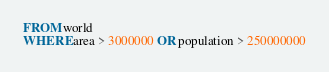Convert code to text. <code><loc_0><loc_0><loc_500><loc_500><_SQL_>FROM world
WHERE area > 3000000 OR population > 250000000
</code> 